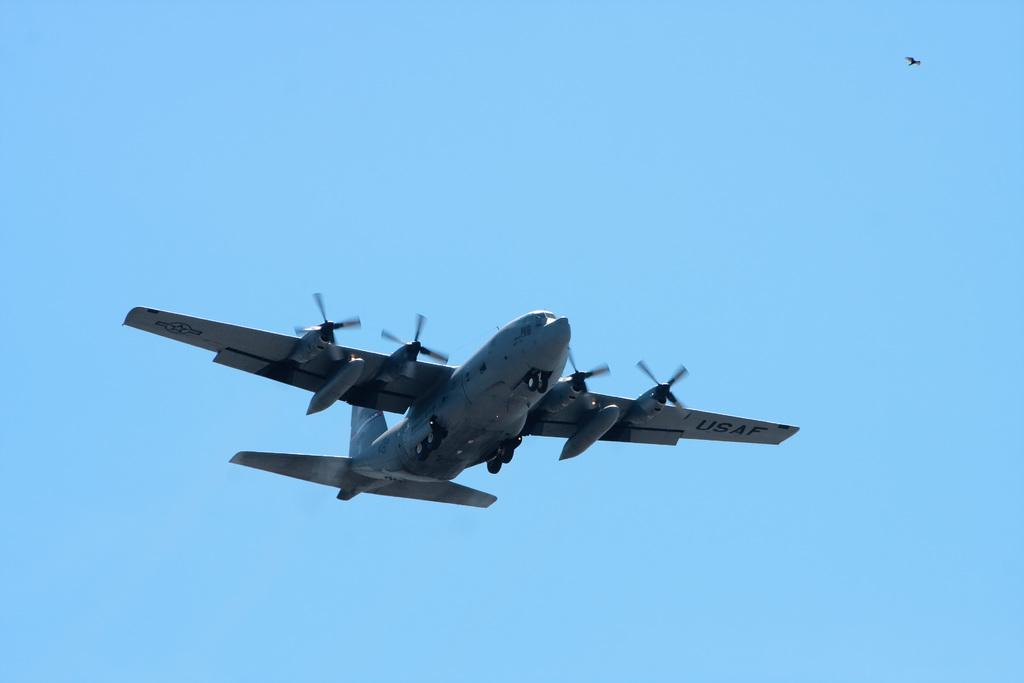What is the main subject of the image? There is an aeroplane flying in the image. What can be seen in the background of the image? The sky is visible in the background of the image. What is the color of the sky in the image? The color of the sky is blue. Can you spot any other flying objects in the image? Yes, there is a bird flying in the top right-hand corner of the image. Where is the vase placed in the image? There is no vase present in the image. What type of frog can be seen writing a letter in the image? There is no frog or writing activity in the image. 